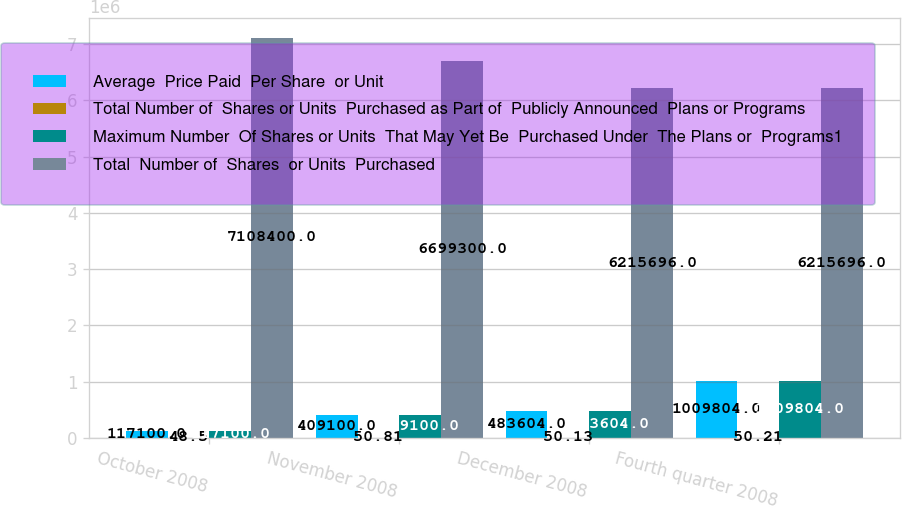Convert chart. <chart><loc_0><loc_0><loc_500><loc_500><stacked_bar_chart><ecel><fcel>October 2008<fcel>November 2008<fcel>December 2008<fcel>Fourth quarter 2008<nl><fcel>Average  Price Paid  Per Share  or Unit<fcel>117100<fcel>409100<fcel>483604<fcel>1.0098e+06<nl><fcel>Total Number of  Shares or Units  Purchased as Part of  Publicly Announced  Plans or Programs<fcel>48.5<fcel>50.81<fcel>50.13<fcel>50.21<nl><fcel>Maximum Number  Of Shares or Units  That May Yet Be  Purchased Under  The Plans or  Programs1<fcel>117100<fcel>409100<fcel>483604<fcel>1.0098e+06<nl><fcel>Total  Number of  Shares  or Units  Purchased<fcel>7.1084e+06<fcel>6.6993e+06<fcel>6.2157e+06<fcel>6.2157e+06<nl></chart> 